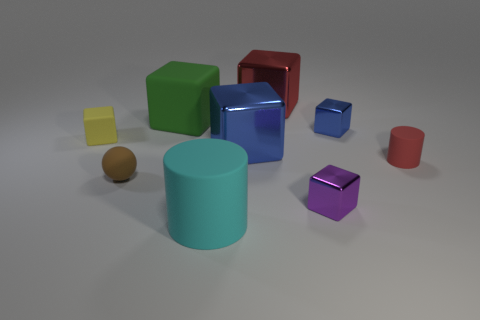Is the color of the big rubber cube the same as the tiny sphere? no 